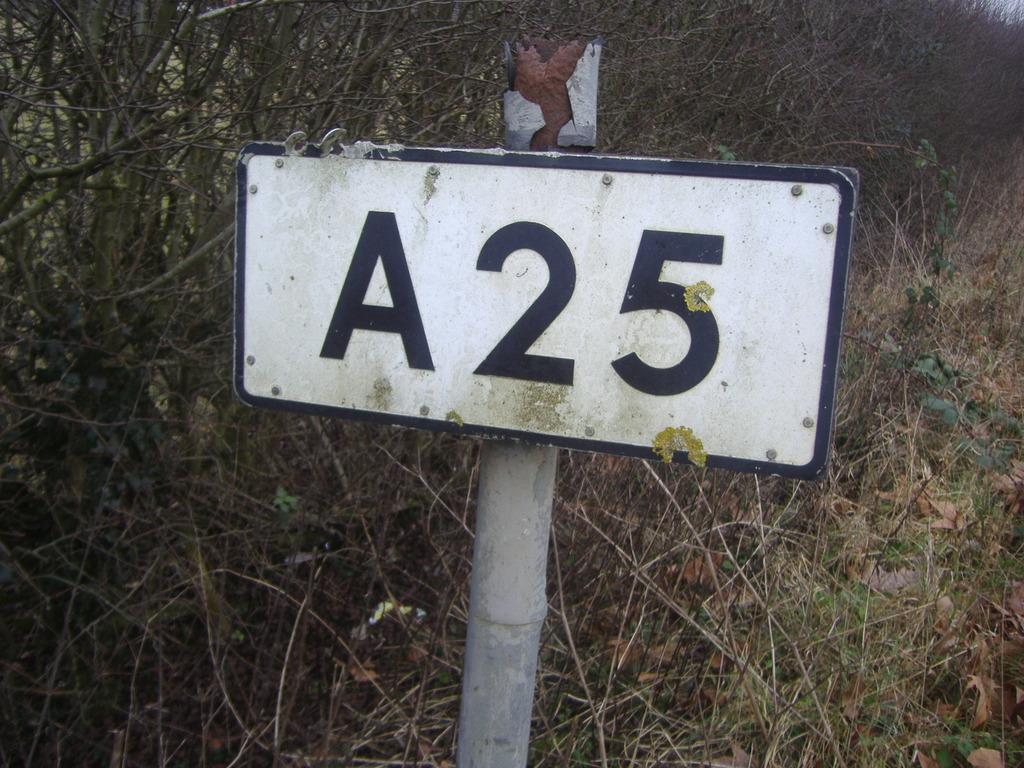Describe this image in one or two sentences. In this we can see a pole with a number plate on it and in the background, we can see some plants and grass. 